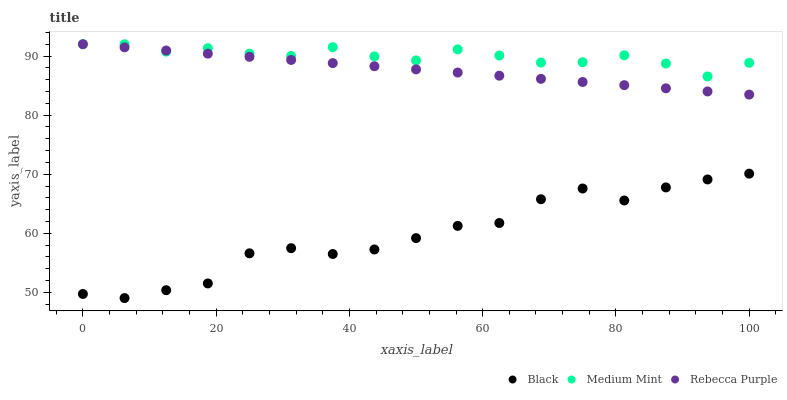Does Black have the minimum area under the curve?
Answer yes or no. Yes. Does Medium Mint have the maximum area under the curve?
Answer yes or no. Yes. Does Rebecca Purple have the minimum area under the curve?
Answer yes or no. No. Does Rebecca Purple have the maximum area under the curve?
Answer yes or no. No. Is Rebecca Purple the smoothest?
Answer yes or no. Yes. Is Black the roughest?
Answer yes or no. Yes. Is Black the smoothest?
Answer yes or no. No. Is Rebecca Purple the roughest?
Answer yes or no. No. Does Black have the lowest value?
Answer yes or no. Yes. Does Rebecca Purple have the lowest value?
Answer yes or no. No. Does Rebecca Purple have the highest value?
Answer yes or no. Yes. Does Black have the highest value?
Answer yes or no. No. Is Black less than Rebecca Purple?
Answer yes or no. Yes. Is Rebecca Purple greater than Black?
Answer yes or no. Yes. Does Rebecca Purple intersect Medium Mint?
Answer yes or no. Yes. Is Rebecca Purple less than Medium Mint?
Answer yes or no. No. Is Rebecca Purple greater than Medium Mint?
Answer yes or no. No. Does Black intersect Rebecca Purple?
Answer yes or no. No. 